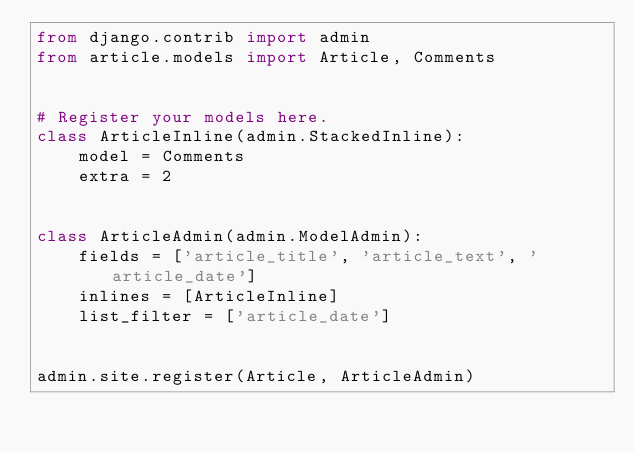<code> <loc_0><loc_0><loc_500><loc_500><_Python_>from django.contrib import admin
from article.models import Article, Comments


# Register your models here.
class ArticleInline(admin.StackedInline):
    model = Comments
    extra = 2


class ArticleAdmin(admin.ModelAdmin):
    fields = ['article_title', 'article_text', 'article_date']
    inlines = [ArticleInline]
    list_filter = ['article_date']


admin.site.register(Article, ArticleAdmin)
</code> 